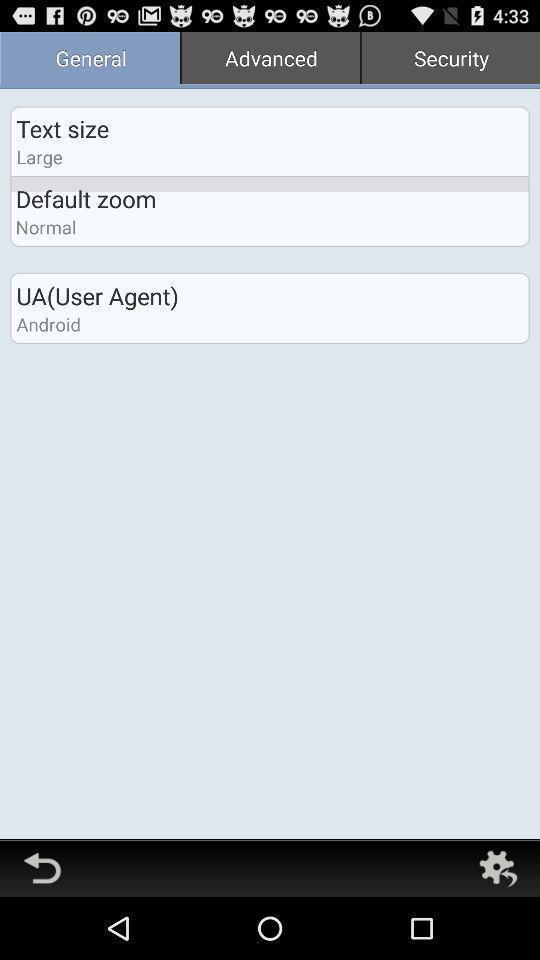What can you discern from this picture? Text size in a general. 